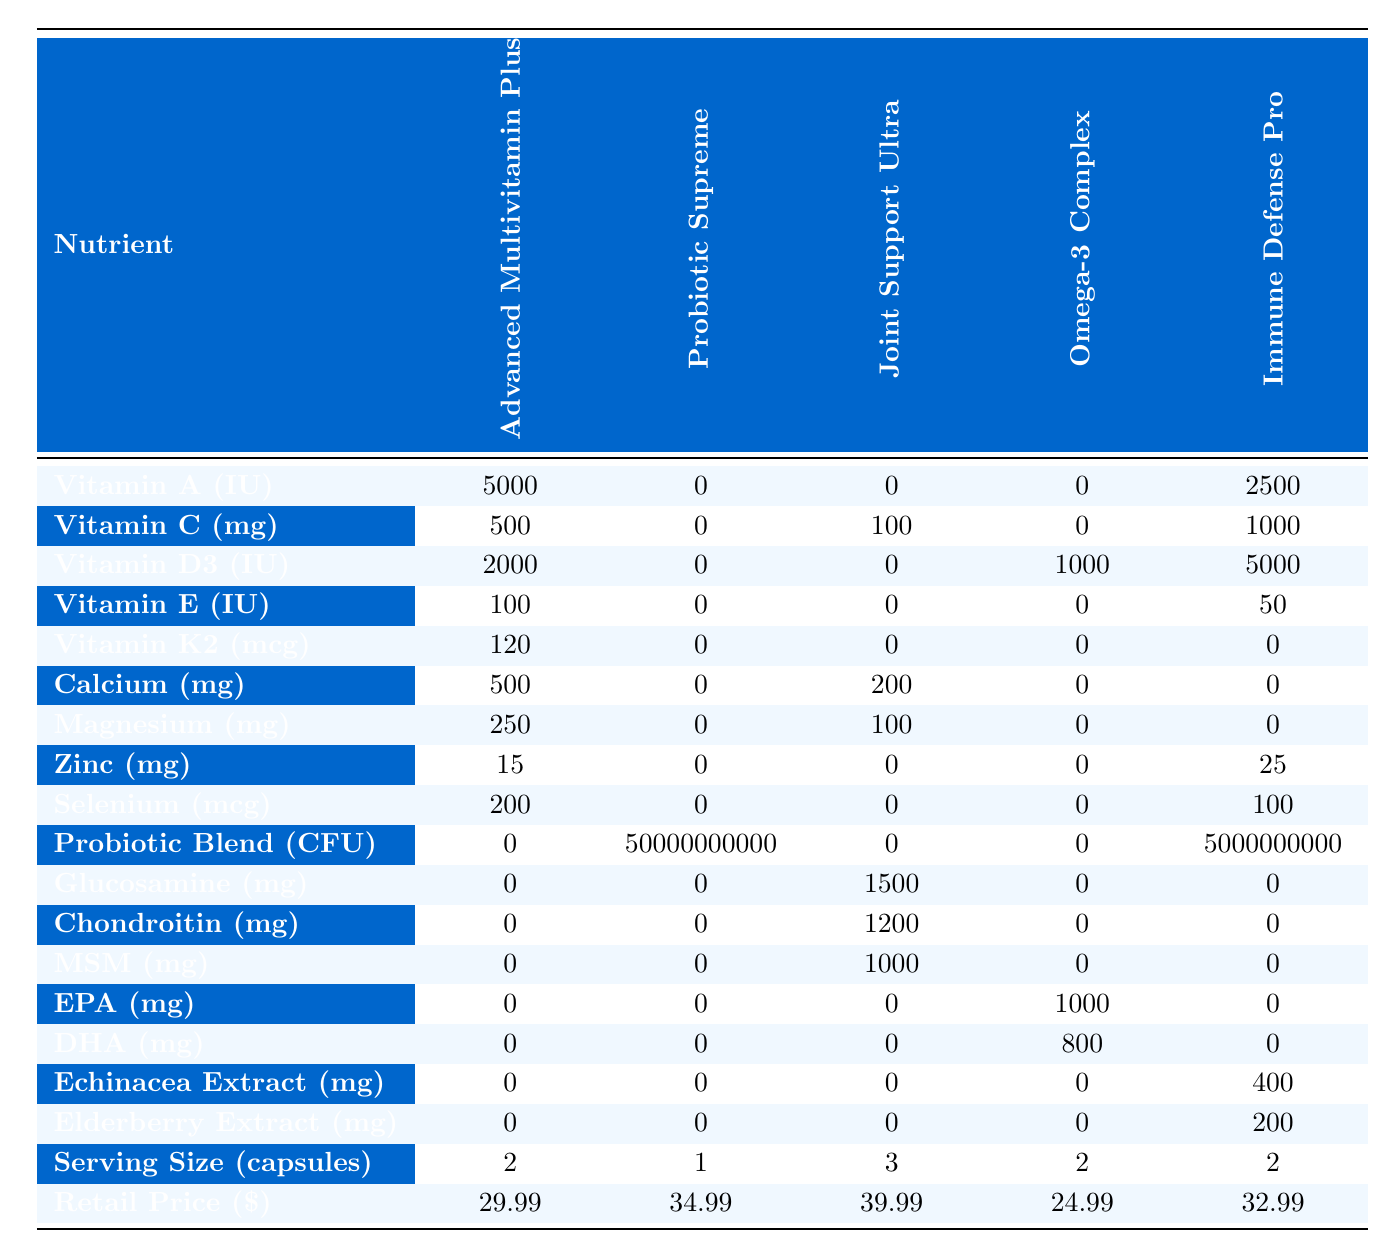What is the highest amount of Vitamin C among the supplements? By looking at the Vitamin C row, we see that the highest value is 1000 mg in the Immune Defense Pro formulation.
Answer: 1000 mg Which supplement contains the most Zinc? Checking the Zinc row, the Immune Defense Pro has 25 mg, which is higher than the 15 mg in Advanced Multivitamin Plus and 0 in the other formulations.
Answer: Immune Defense Pro How many supplements contain Glucosamine? Looking at the Glucosamine row, only the Joint Support Ultra contains Glucosamine at 1500 mg, while others have 0 mg.
Answer: 1 What is the total serving size of all supplements combined? Summing the serving sizes from all supplements: 2 + 1 + 3 + 2 + 2 = 10 capsules total.
Answer: 10 capsules Which supplement has the most variety of listed nutrients? The Advanced Multivitamin Plus contains 14 nutrients listed, while others have fewer; hence, it has the most variety.
Answer: Advanced Multivitamin Plus Is there any supplement that does not contain Vitamin E? In the Vitamin E row, both Probiotic Supreme, Joint Support Ultra, and Omega-3 Complex show 0, meaning they do not contain Vitamin E.
Answer: Yes What is the average Retail Price of the Omega-3 Complex and Probiotic Supreme? Adding the retail prices of both: 24.99 + 34.99 = 59.98, then dividing by 2 gives an average of 29.99.
Answer: 29.99 Which supplement has the highest content of Probiotic Blend? The Probiotic Supreme contains 50,000,000,000 CFU of Probiotic Blend, which is the highest compared to others that have 0.
Answer: Probiotic Supreme What is the difference in Vitamin D3 content between Immune Defense Pro and Omega-3 Complex? The Immune Defense Pro has 5000 IU of Vitamin D3, while Omega-3 Complex has 1000 IU; the difference is 5000 - 1000 = 4000 IU.
Answer: 4000 IU Does any formulation contain both Elderberry and Echinacea Extract? The table shows Elderberry Extract has 200 mg in Immune Defense Pro, and Echinacea Extract also has 400 mg in the same, confirming both are present in this formulation.
Answer: Yes 